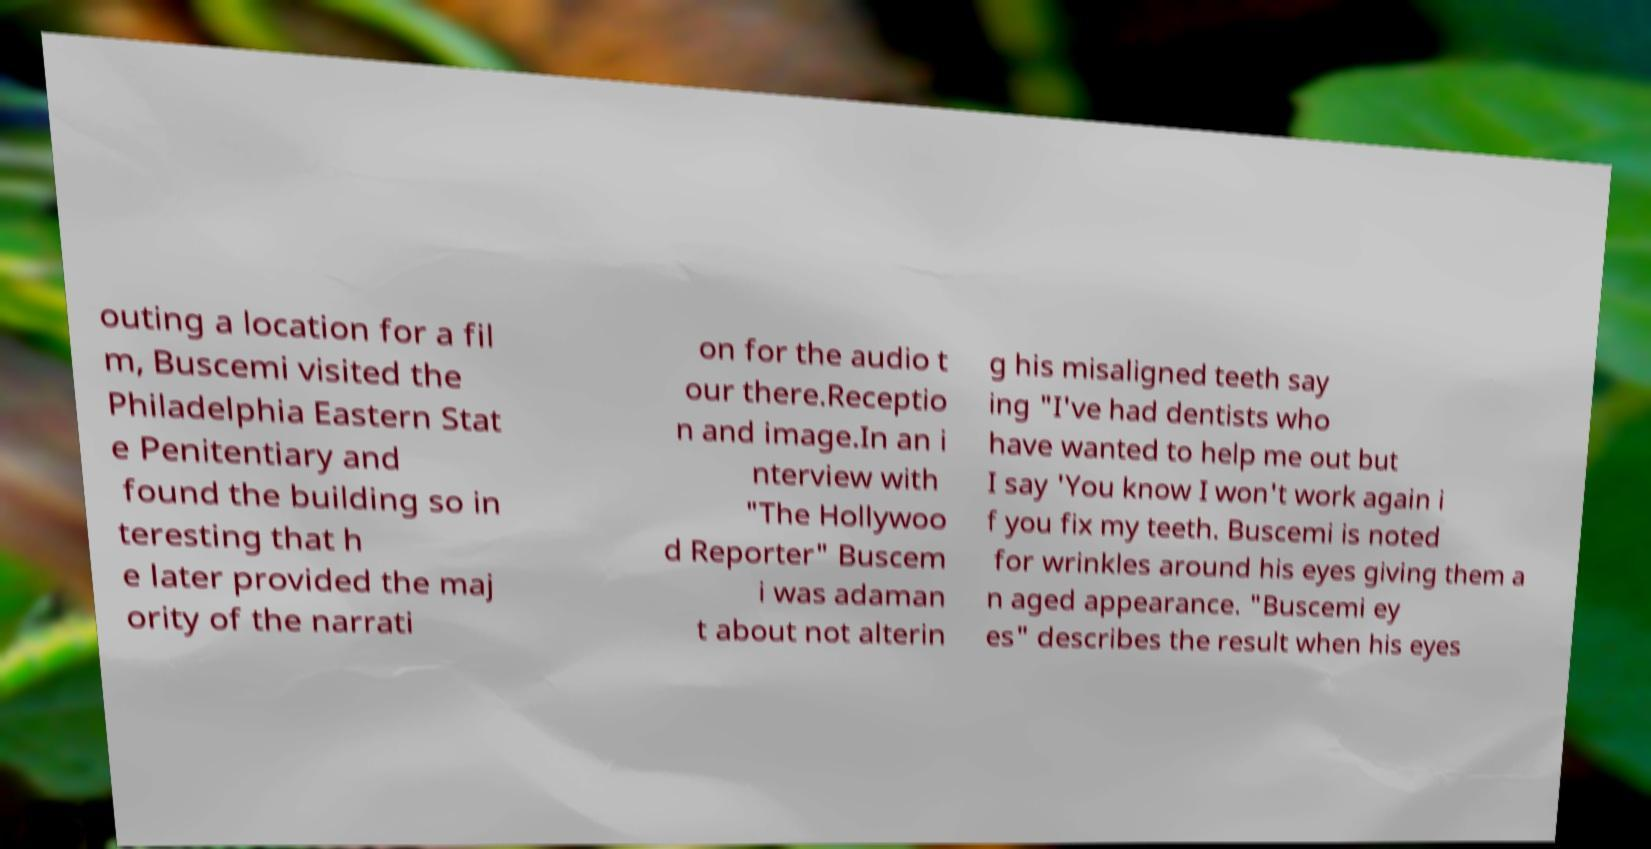Can you read and provide the text displayed in the image?This photo seems to have some interesting text. Can you extract and type it out for me? outing a location for a fil m, Buscemi visited the Philadelphia Eastern Stat e Penitentiary and found the building so in teresting that h e later provided the maj ority of the narrati on for the audio t our there.Receptio n and image.In an i nterview with "The Hollywoo d Reporter" Buscem i was adaman t about not alterin g his misaligned teeth say ing "I've had dentists who have wanted to help me out but I say 'You know I won't work again i f you fix my teeth. Buscemi is noted for wrinkles around his eyes giving them a n aged appearance. "Buscemi ey es" describes the result when his eyes 